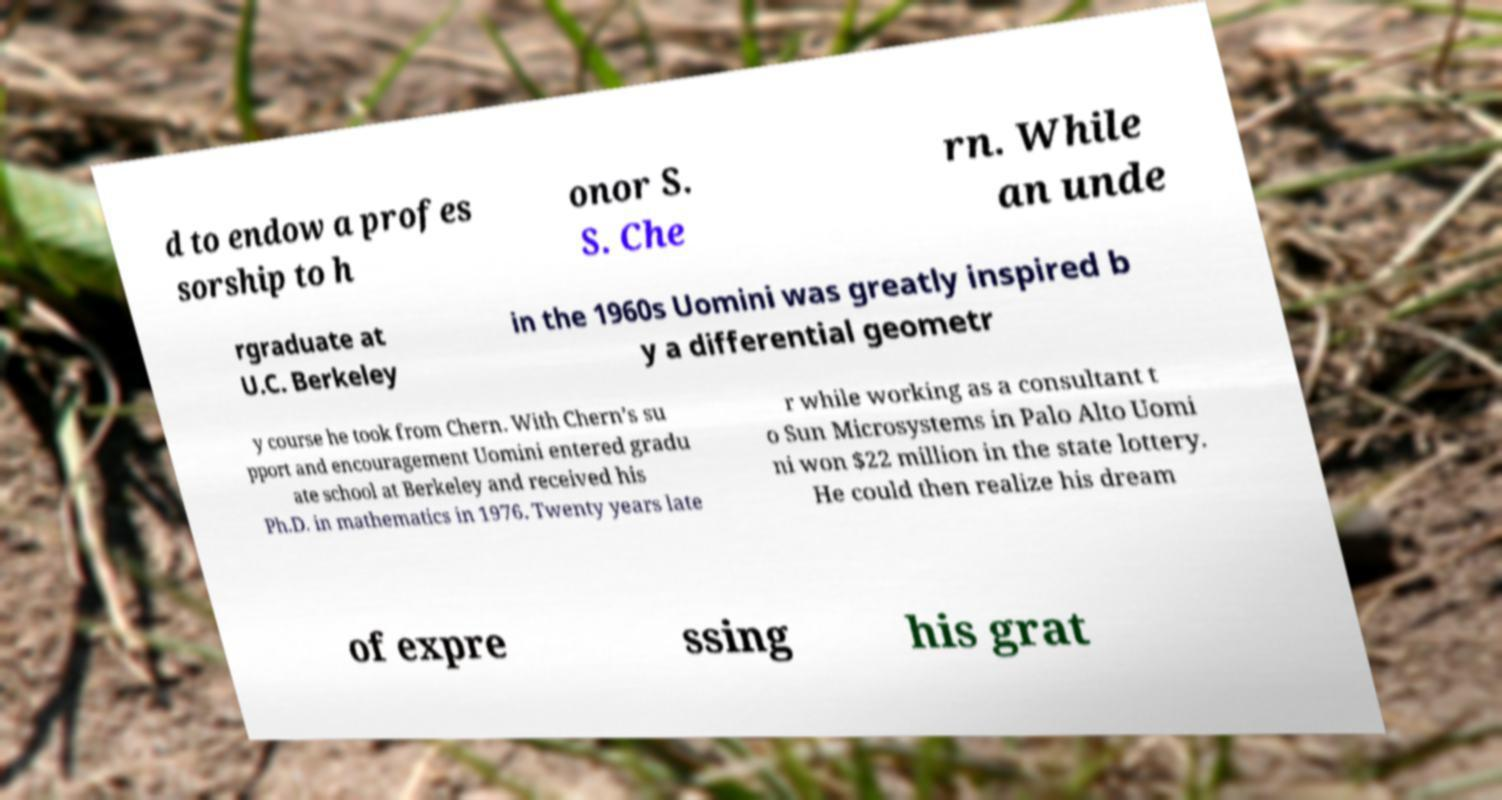Please read and relay the text visible in this image. What does it say? d to endow a profes sorship to h onor S. S. Che rn. While an unde rgraduate at U.C. Berkeley in the 1960s Uomini was greatly inspired b y a differential geometr y course he took from Chern. With Chern’s su pport and encouragement Uomini entered gradu ate school at Berkeley and received his Ph.D. in mathematics in 1976. Twenty years late r while working as a consultant t o Sun Microsystems in Palo Alto Uomi ni won $22 million in the state lottery. He could then realize his dream of expre ssing his grat 